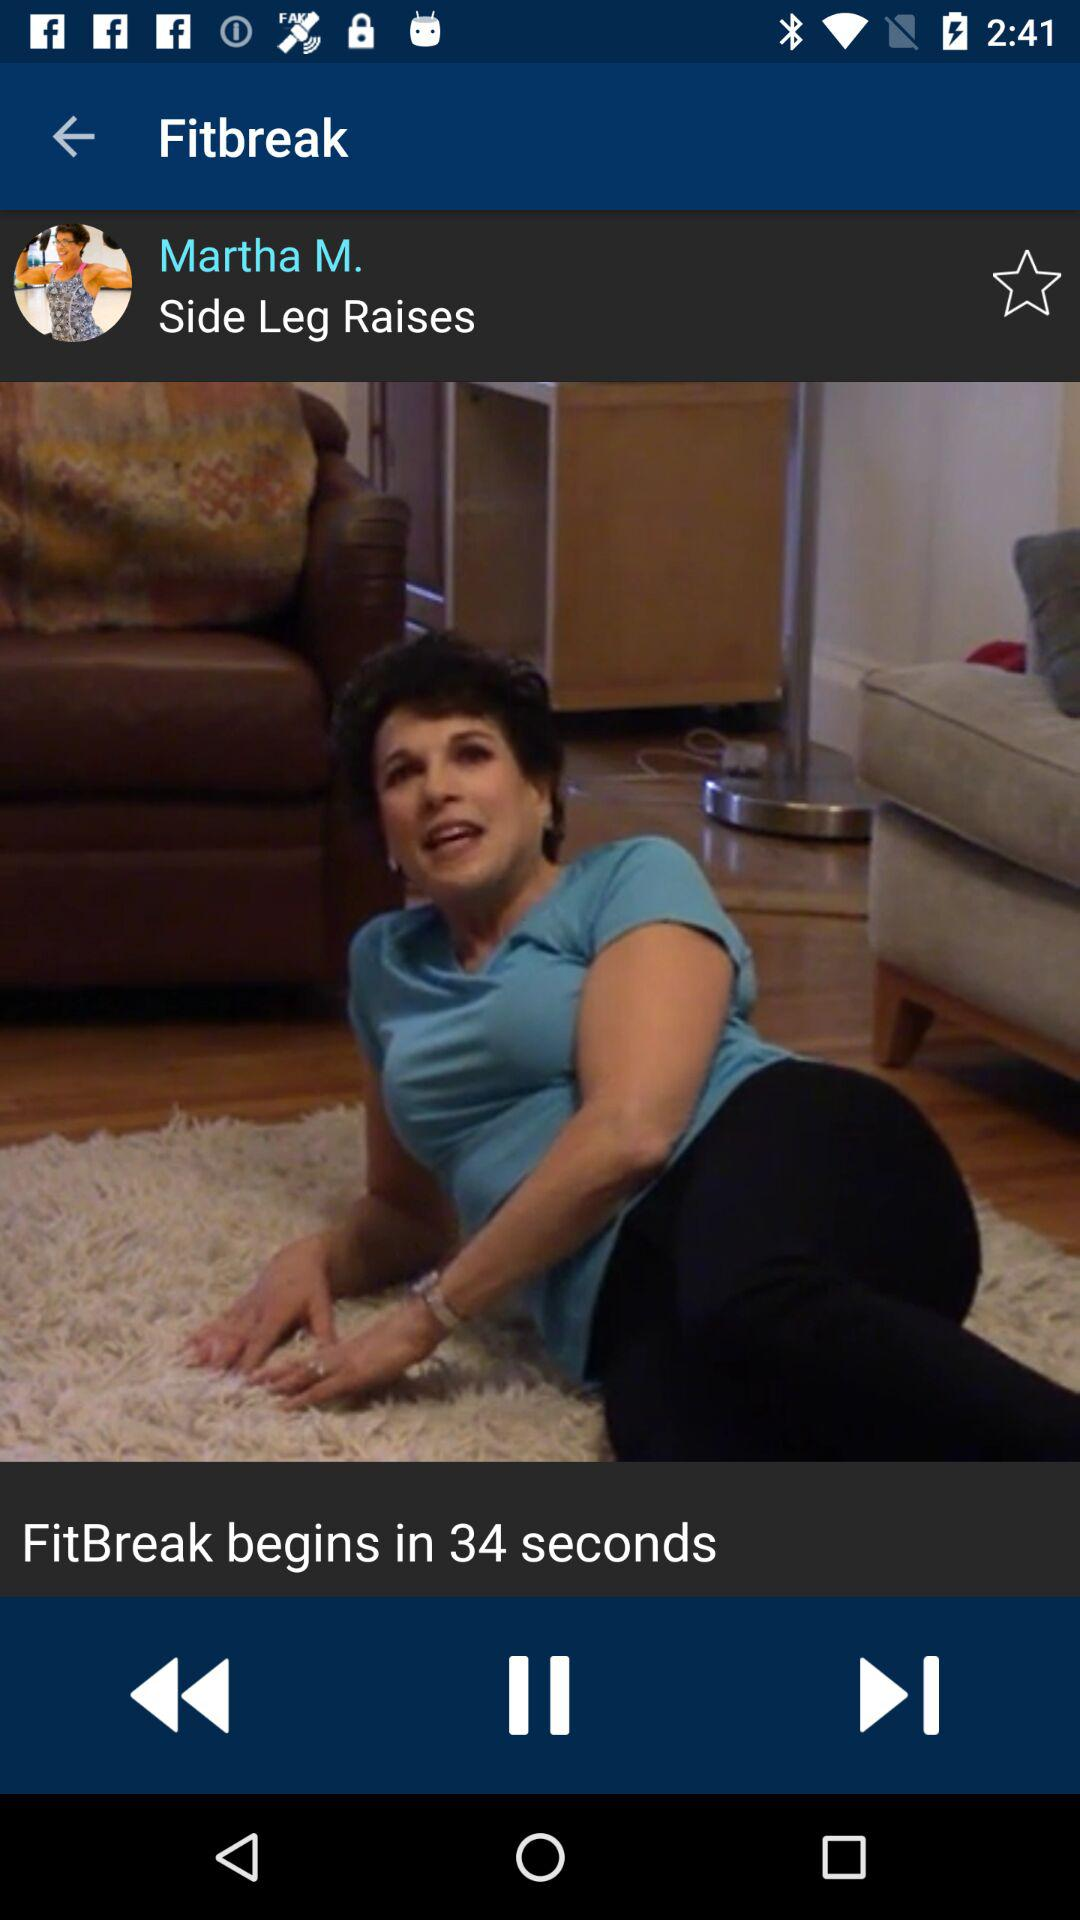In how many seconds will the fitbreak begin? The fitbreak will begin in 34 seconds. 